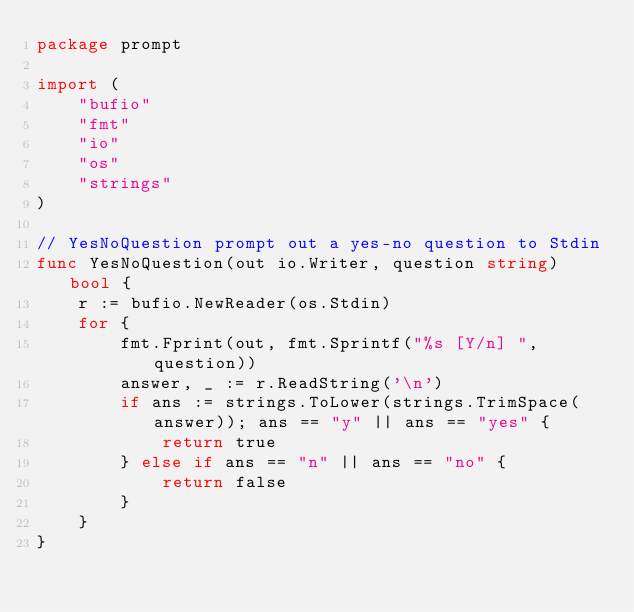Convert code to text. <code><loc_0><loc_0><loc_500><loc_500><_Go_>package prompt

import (
	"bufio"
	"fmt"
	"io"
	"os"
	"strings"
)

// YesNoQuestion prompt out a yes-no question to Stdin
func YesNoQuestion(out io.Writer, question string) bool {
	r := bufio.NewReader(os.Stdin)
	for {
		fmt.Fprint(out, fmt.Sprintf("%s [Y/n] ", question))
		answer, _ := r.ReadString('\n')
		if ans := strings.ToLower(strings.TrimSpace(answer)); ans == "y" || ans == "yes" {
			return true
		} else if ans == "n" || ans == "no" {
			return false
		}
	}
}
</code> 